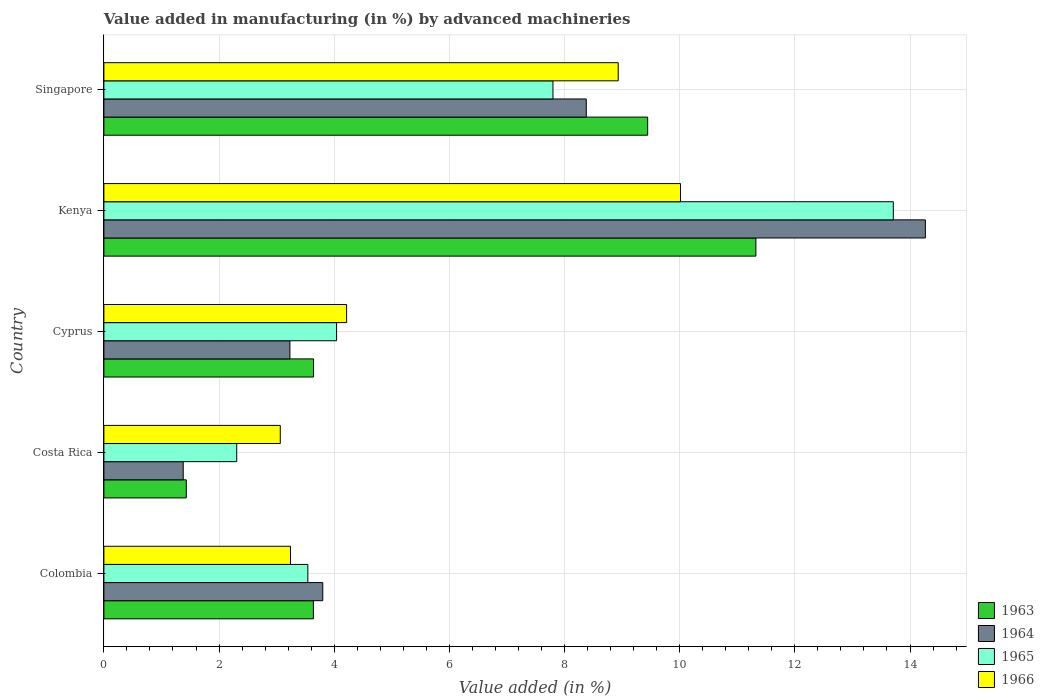Are the number of bars per tick equal to the number of legend labels?
Provide a short and direct response. Yes. How many bars are there on the 2nd tick from the bottom?
Make the answer very short. 4. In how many cases, is the number of bars for a given country not equal to the number of legend labels?
Give a very brief answer. 0. What is the percentage of value added in manufacturing by advanced machineries in 1965 in Singapore?
Provide a short and direct response. 7.8. Across all countries, what is the maximum percentage of value added in manufacturing by advanced machineries in 1966?
Your response must be concise. 10.01. Across all countries, what is the minimum percentage of value added in manufacturing by advanced machineries in 1965?
Your answer should be very brief. 2.31. In which country was the percentage of value added in manufacturing by advanced machineries in 1966 maximum?
Provide a short and direct response. Kenya. In which country was the percentage of value added in manufacturing by advanced machineries in 1964 minimum?
Ensure brevity in your answer.  Costa Rica. What is the total percentage of value added in manufacturing by advanced machineries in 1966 in the graph?
Keep it short and to the point. 29.47. What is the difference between the percentage of value added in manufacturing by advanced machineries in 1965 in Costa Rica and that in Cyprus?
Your answer should be compact. -1.73. What is the difference between the percentage of value added in manufacturing by advanced machineries in 1966 in Kenya and the percentage of value added in manufacturing by advanced machineries in 1963 in Costa Rica?
Keep it short and to the point. 8.58. What is the average percentage of value added in manufacturing by advanced machineries in 1966 per country?
Keep it short and to the point. 5.89. What is the difference between the percentage of value added in manufacturing by advanced machineries in 1963 and percentage of value added in manufacturing by advanced machineries in 1966 in Singapore?
Make the answer very short. 0.51. What is the ratio of the percentage of value added in manufacturing by advanced machineries in 1966 in Cyprus to that in Singapore?
Offer a very short reply. 0.47. What is the difference between the highest and the second highest percentage of value added in manufacturing by advanced machineries in 1964?
Provide a succinct answer. 5.89. What is the difference between the highest and the lowest percentage of value added in manufacturing by advanced machineries in 1965?
Offer a very short reply. 11.4. In how many countries, is the percentage of value added in manufacturing by advanced machineries in 1966 greater than the average percentage of value added in manufacturing by advanced machineries in 1966 taken over all countries?
Keep it short and to the point. 2. What does the 2nd bar from the top in Kenya represents?
Keep it short and to the point. 1965. Is it the case that in every country, the sum of the percentage of value added in manufacturing by advanced machineries in 1964 and percentage of value added in manufacturing by advanced machineries in 1965 is greater than the percentage of value added in manufacturing by advanced machineries in 1966?
Offer a very short reply. Yes. How many bars are there?
Give a very brief answer. 20. What is the difference between two consecutive major ticks on the X-axis?
Your response must be concise. 2. Are the values on the major ticks of X-axis written in scientific E-notation?
Make the answer very short. No. Does the graph contain any zero values?
Provide a succinct answer. No. Where does the legend appear in the graph?
Ensure brevity in your answer.  Bottom right. How many legend labels are there?
Provide a succinct answer. 4. What is the title of the graph?
Provide a succinct answer. Value added in manufacturing (in %) by advanced machineries. What is the label or title of the X-axis?
Your answer should be compact. Value added (in %). What is the label or title of the Y-axis?
Your answer should be compact. Country. What is the Value added (in %) of 1963 in Colombia?
Your answer should be compact. 3.64. What is the Value added (in %) of 1964 in Colombia?
Give a very brief answer. 3.8. What is the Value added (in %) of 1965 in Colombia?
Ensure brevity in your answer.  3.54. What is the Value added (in %) in 1966 in Colombia?
Make the answer very short. 3.24. What is the Value added (in %) in 1963 in Costa Rica?
Give a very brief answer. 1.43. What is the Value added (in %) of 1964 in Costa Rica?
Ensure brevity in your answer.  1.38. What is the Value added (in %) of 1965 in Costa Rica?
Make the answer very short. 2.31. What is the Value added (in %) in 1966 in Costa Rica?
Offer a terse response. 3.06. What is the Value added (in %) in 1963 in Cyprus?
Your response must be concise. 3.64. What is the Value added (in %) of 1964 in Cyprus?
Provide a succinct answer. 3.23. What is the Value added (in %) of 1965 in Cyprus?
Your response must be concise. 4.04. What is the Value added (in %) of 1966 in Cyprus?
Give a very brief answer. 4.22. What is the Value added (in %) of 1963 in Kenya?
Make the answer very short. 11.32. What is the Value added (in %) of 1964 in Kenya?
Keep it short and to the point. 14.27. What is the Value added (in %) of 1965 in Kenya?
Give a very brief answer. 13.71. What is the Value added (in %) in 1966 in Kenya?
Provide a short and direct response. 10.01. What is the Value added (in %) in 1963 in Singapore?
Keep it short and to the point. 9.44. What is the Value added (in %) in 1964 in Singapore?
Your answer should be very brief. 8.38. What is the Value added (in %) of 1965 in Singapore?
Give a very brief answer. 7.8. What is the Value added (in %) in 1966 in Singapore?
Your response must be concise. 8.93. Across all countries, what is the maximum Value added (in %) in 1963?
Make the answer very short. 11.32. Across all countries, what is the maximum Value added (in %) in 1964?
Your answer should be compact. 14.27. Across all countries, what is the maximum Value added (in %) in 1965?
Keep it short and to the point. 13.71. Across all countries, what is the maximum Value added (in %) of 1966?
Make the answer very short. 10.01. Across all countries, what is the minimum Value added (in %) in 1963?
Ensure brevity in your answer.  1.43. Across all countries, what is the minimum Value added (in %) in 1964?
Give a very brief answer. 1.38. Across all countries, what is the minimum Value added (in %) in 1965?
Make the answer very short. 2.31. Across all countries, what is the minimum Value added (in %) in 1966?
Offer a very short reply. 3.06. What is the total Value added (in %) in 1963 in the graph?
Offer a terse response. 29.48. What is the total Value added (in %) of 1964 in the graph?
Provide a short and direct response. 31.05. What is the total Value added (in %) of 1965 in the graph?
Your response must be concise. 31.4. What is the total Value added (in %) in 1966 in the graph?
Your answer should be very brief. 29.47. What is the difference between the Value added (in %) in 1963 in Colombia and that in Costa Rica?
Provide a succinct answer. 2.21. What is the difference between the Value added (in %) of 1964 in Colombia and that in Costa Rica?
Offer a terse response. 2.42. What is the difference between the Value added (in %) in 1965 in Colombia and that in Costa Rica?
Your answer should be very brief. 1.24. What is the difference between the Value added (in %) in 1966 in Colombia and that in Costa Rica?
Give a very brief answer. 0.18. What is the difference between the Value added (in %) in 1963 in Colombia and that in Cyprus?
Make the answer very short. -0. What is the difference between the Value added (in %) in 1964 in Colombia and that in Cyprus?
Give a very brief answer. 0.57. What is the difference between the Value added (in %) of 1965 in Colombia and that in Cyprus?
Keep it short and to the point. -0.5. What is the difference between the Value added (in %) of 1966 in Colombia and that in Cyprus?
Provide a succinct answer. -0.97. What is the difference between the Value added (in %) in 1963 in Colombia and that in Kenya?
Your answer should be very brief. -7.69. What is the difference between the Value added (in %) of 1964 in Colombia and that in Kenya?
Your answer should be very brief. -10.47. What is the difference between the Value added (in %) in 1965 in Colombia and that in Kenya?
Ensure brevity in your answer.  -10.17. What is the difference between the Value added (in %) of 1966 in Colombia and that in Kenya?
Offer a very short reply. -6.77. What is the difference between the Value added (in %) in 1963 in Colombia and that in Singapore?
Offer a terse response. -5.81. What is the difference between the Value added (in %) of 1964 in Colombia and that in Singapore?
Offer a terse response. -4.58. What is the difference between the Value added (in %) of 1965 in Colombia and that in Singapore?
Ensure brevity in your answer.  -4.26. What is the difference between the Value added (in %) of 1966 in Colombia and that in Singapore?
Provide a succinct answer. -5.69. What is the difference between the Value added (in %) in 1963 in Costa Rica and that in Cyprus?
Provide a short and direct response. -2.21. What is the difference between the Value added (in %) of 1964 in Costa Rica and that in Cyprus?
Make the answer very short. -1.85. What is the difference between the Value added (in %) of 1965 in Costa Rica and that in Cyprus?
Provide a succinct answer. -1.73. What is the difference between the Value added (in %) in 1966 in Costa Rica and that in Cyprus?
Keep it short and to the point. -1.15. What is the difference between the Value added (in %) in 1963 in Costa Rica and that in Kenya?
Ensure brevity in your answer.  -9.89. What is the difference between the Value added (in %) in 1964 in Costa Rica and that in Kenya?
Make the answer very short. -12.89. What is the difference between the Value added (in %) of 1965 in Costa Rica and that in Kenya?
Keep it short and to the point. -11.4. What is the difference between the Value added (in %) in 1966 in Costa Rica and that in Kenya?
Provide a short and direct response. -6.95. What is the difference between the Value added (in %) in 1963 in Costa Rica and that in Singapore?
Provide a short and direct response. -8.01. What is the difference between the Value added (in %) in 1964 in Costa Rica and that in Singapore?
Offer a terse response. -7. What is the difference between the Value added (in %) of 1965 in Costa Rica and that in Singapore?
Your answer should be very brief. -5.49. What is the difference between the Value added (in %) in 1966 in Costa Rica and that in Singapore?
Your answer should be very brief. -5.87. What is the difference between the Value added (in %) in 1963 in Cyprus and that in Kenya?
Ensure brevity in your answer.  -7.68. What is the difference between the Value added (in %) of 1964 in Cyprus and that in Kenya?
Provide a succinct answer. -11.04. What is the difference between the Value added (in %) in 1965 in Cyprus and that in Kenya?
Your response must be concise. -9.67. What is the difference between the Value added (in %) of 1966 in Cyprus and that in Kenya?
Give a very brief answer. -5.8. What is the difference between the Value added (in %) of 1963 in Cyprus and that in Singapore?
Give a very brief answer. -5.8. What is the difference between the Value added (in %) in 1964 in Cyprus and that in Singapore?
Make the answer very short. -5.15. What is the difference between the Value added (in %) of 1965 in Cyprus and that in Singapore?
Keep it short and to the point. -3.76. What is the difference between the Value added (in %) of 1966 in Cyprus and that in Singapore?
Offer a very short reply. -4.72. What is the difference between the Value added (in %) of 1963 in Kenya and that in Singapore?
Make the answer very short. 1.88. What is the difference between the Value added (in %) in 1964 in Kenya and that in Singapore?
Give a very brief answer. 5.89. What is the difference between the Value added (in %) in 1965 in Kenya and that in Singapore?
Your answer should be compact. 5.91. What is the difference between the Value added (in %) of 1966 in Kenya and that in Singapore?
Provide a short and direct response. 1.08. What is the difference between the Value added (in %) of 1963 in Colombia and the Value added (in %) of 1964 in Costa Rica?
Offer a terse response. 2.26. What is the difference between the Value added (in %) in 1963 in Colombia and the Value added (in %) in 1965 in Costa Rica?
Keep it short and to the point. 1.33. What is the difference between the Value added (in %) in 1963 in Colombia and the Value added (in %) in 1966 in Costa Rica?
Your answer should be very brief. 0.57. What is the difference between the Value added (in %) of 1964 in Colombia and the Value added (in %) of 1965 in Costa Rica?
Your answer should be very brief. 1.49. What is the difference between the Value added (in %) in 1964 in Colombia and the Value added (in %) in 1966 in Costa Rica?
Provide a succinct answer. 0.74. What is the difference between the Value added (in %) in 1965 in Colombia and the Value added (in %) in 1966 in Costa Rica?
Ensure brevity in your answer.  0.48. What is the difference between the Value added (in %) in 1963 in Colombia and the Value added (in %) in 1964 in Cyprus?
Offer a terse response. 0.41. What is the difference between the Value added (in %) in 1963 in Colombia and the Value added (in %) in 1965 in Cyprus?
Offer a terse response. -0.4. What is the difference between the Value added (in %) in 1963 in Colombia and the Value added (in %) in 1966 in Cyprus?
Ensure brevity in your answer.  -0.58. What is the difference between the Value added (in %) in 1964 in Colombia and the Value added (in %) in 1965 in Cyprus?
Your answer should be very brief. -0.24. What is the difference between the Value added (in %) of 1964 in Colombia and the Value added (in %) of 1966 in Cyprus?
Ensure brevity in your answer.  -0.41. What is the difference between the Value added (in %) of 1965 in Colombia and the Value added (in %) of 1966 in Cyprus?
Keep it short and to the point. -0.67. What is the difference between the Value added (in %) in 1963 in Colombia and the Value added (in %) in 1964 in Kenya?
Provide a succinct answer. -10.63. What is the difference between the Value added (in %) of 1963 in Colombia and the Value added (in %) of 1965 in Kenya?
Provide a succinct answer. -10.07. What is the difference between the Value added (in %) in 1963 in Colombia and the Value added (in %) in 1966 in Kenya?
Provide a succinct answer. -6.38. What is the difference between the Value added (in %) of 1964 in Colombia and the Value added (in %) of 1965 in Kenya?
Make the answer very short. -9.91. What is the difference between the Value added (in %) in 1964 in Colombia and the Value added (in %) in 1966 in Kenya?
Ensure brevity in your answer.  -6.21. What is the difference between the Value added (in %) in 1965 in Colombia and the Value added (in %) in 1966 in Kenya?
Provide a succinct answer. -6.47. What is the difference between the Value added (in %) of 1963 in Colombia and the Value added (in %) of 1964 in Singapore?
Your response must be concise. -4.74. What is the difference between the Value added (in %) of 1963 in Colombia and the Value added (in %) of 1965 in Singapore?
Provide a short and direct response. -4.16. What is the difference between the Value added (in %) in 1963 in Colombia and the Value added (in %) in 1966 in Singapore?
Offer a terse response. -5.29. What is the difference between the Value added (in %) of 1964 in Colombia and the Value added (in %) of 1965 in Singapore?
Keep it short and to the point. -4. What is the difference between the Value added (in %) in 1964 in Colombia and the Value added (in %) in 1966 in Singapore?
Your response must be concise. -5.13. What is the difference between the Value added (in %) of 1965 in Colombia and the Value added (in %) of 1966 in Singapore?
Your answer should be compact. -5.39. What is the difference between the Value added (in %) of 1963 in Costa Rica and the Value added (in %) of 1964 in Cyprus?
Make the answer very short. -1.8. What is the difference between the Value added (in %) of 1963 in Costa Rica and the Value added (in %) of 1965 in Cyprus?
Your answer should be very brief. -2.61. What is the difference between the Value added (in %) in 1963 in Costa Rica and the Value added (in %) in 1966 in Cyprus?
Provide a short and direct response. -2.78. What is the difference between the Value added (in %) in 1964 in Costa Rica and the Value added (in %) in 1965 in Cyprus?
Provide a succinct answer. -2.66. What is the difference between the Value added (in %) of 1964 in Costa Rica and the Value added (in %) of 1966 in Cyprus?
Offer a very short reply. -2.84. What is the difference between the Value added (in %) of 1965 in Costa Rica and the Value added (in %) of 1966 in Cyprus?
Your answer should be compact. -1.91. What is the difference between the Value added (in %) of 1963 in Costa Rica and the Value added (in %) of 1964 in Kenya?
Make the answer very short. -12.84. What is the difference between the Value added (in %) of 1963 in Costa Rica and the Value added (in %) of 1965 in Kenya?
Ensure brevity in your answer.  -12.28. What is the difference between the Value added (in %) in 1963 in Costa Rica and the Value added (in %) in 1966 in Kenya?
Provide a short and direct response. -8.58. What is the difference between the Value added (in %) of 1964 in Costa Rica and the Value added (in %) of 1965 in Kenya?
Your answer should be compact. -12.33. What is the difference between the Value added (in %) of 1964 in Costa Rica and the Value added (in %) of 1966 in Kenya?
Your answer should be very brief. -8.64. What is the difference between the Value added (in %) in 1965 in Costa Rica and the Value added (in %) in 1966 in Kenya?
Your answer should be very brief. -7.71. What is the difference between the Value added (in %) in 1963 in Costa Rica and the Value added (in %) in 1964 in Singapore?
Your answer should be very brief. -6.95. What is the difference between the Value added (in %) of 1963 in Costa Rica and the Value added (in %) of 1965 in Singapore?
Make the answer very short. -6.37. What is the difference between the Value added (in %) in 1963 in Costa Rica and the Value added (in %) in 1966 in Singapore?
Provide a short and direct response. -7.5. What is the difference between the Value added (in %) of 1964 in Costa Rica and the Value added (in %) of 1965 in Singapore?
Keep it short and to the point. -6.42. What is the difference between the Value added (in %) of 1964 in Costa Rica and the Value added (in %) of 1966 in Singapore?
Keep it short and to the point. -7.55. What is the difference between the Value added (in %) of 1965 in Costa Rica and the Value added (in %) of 1966 in Singapore?
Ensure brevity in your answer.  -6.63. What is the difference between the Value added (in %) in 1963 in Cyprus and the Value added (in %) in 1964 in Kenya?
Give a very brief answer. -10.63. What is the difference between the Value added (in %) in 1963 in Cyprus and the Value added (in %) in 1965 in Kenya?
Your answer should be compact. -10.07. What is the difference between the Value added (in %) of 1963 in Cyprus and the Value added (in %) of 1966 in Kenya?
Offer a very short reply. -6.37. What is the difference between the Value added (in %) of 1964 in Cyprus and the Value added (in %) of 1965 in Kenya?
Give a very brief answer. -10.48. What is the difference between the Value added (in %) in 1964 in Cyprus and the Value added (in %) in 1966 in Kenya?
Keep it short and to the point. -6.78. What is the difference between the Value added (in %) in 1965 in Cyprus and the Value added (in %) in 1966 in Kenya?
Make the answer very short. -5.97. What is the difference between the Value added (in %) in 1963 in Cyprus and the Value added (in %) in 1964 in Singapore?
Keep it short and to the point. -4.74. What is the difference between the Value added (in %) of 1963 in Cyprus and the Value added (in %) of 1965 in Singapore?
Offer a very short reply. -4.16. What is the difference between the Value added (in %) in 1963 in Cyprus and the Value added (in %) in 1966 in Singapore?
Your answer should be very brief. -5.29. What is the difference between the Value added (in %) in 1964 in Cyprus and the Value added (in %) in 1965 in Singapore?
Your response must be concise. -4.57. What is the difference between the Value added (in %) of 1964 in Cyprus and the Value added (in %) of 1966 in Singapore?
Keep it short and to the point. -5.7. What is the difference between the Value added (in %) in 1965 in Cyprus and the Value added (in %) in 1966 in Singapore?
Your response must be concise. -4.89. What is the difference between the Value added (in %) of 1963 in Kenya and the Value added (in %) of 1964 in Singapore?
Offer a very short reply. 2.95. What is the difference between the Value added (in %) in 1963 in Kenya and the Value added (in %) in 1965 in Singapore?
Make the answer very short. 3.52. What is the difference between the Value added (in %) in 1963 in Kenya and the Value added (in %) in 1966 in Singapore?
Ensure brevity in your answer.  2.39. What is the difference between the Value added (in %) in 1964 in Kenya and the Value added (in %) in 1965 in Singapore?
Your answer should be compact. 6.47. What is the difference between the Value added (in %) in 1964 in Kenya and the Value added (in %) in 1966 in Singapore?
Offer a terse response. 5.33. What is the difference between the Value added (in %) in 1965 in Kenya and the Value added (in %) in 1966 in Singapore?
Give a very brief answer. 4.78. What is the average Value added (in %) of 1963 per country?
Provide a short and direct response. 5.9. What is the average Value added (in %) of 1964 per country?
Provide a short and direct response. 6.21. What is the average Value added (in %) of 1965 per country?
Make the answer very short. 6.28. What is the average Value added (in %) in 1966 per country?
Provide a short and direct response. 5.89. What is the difference between the Value added (in %) in 1963 and Value added (in %) in 1964 in Colombia?
Your answer should be very brief. -0.16. What is the difference between the Value added (in %) in 1963 and Value added (in %) in 1965 in Colombia?
Keep it short and to the point. 0.1. What is the difference between the Value added (in %) in 1963 and Value added (in %) in 1966 in Colombia?
Give a very brief answer. 0.4. What is the difference between the Value added (in %) of 1964 and Value added (in %) of 1965 in Colombia?
Your response must be concise. 0.26. What is the difference between the Value added (in %) in 1964 and Value added (in %) in 1966 in Colombia?
Give a very brief answer. 0.56. What is the difference between the Value added (in %) in 1965 and Value added (in %) in 1966 in Colombia?
Your answer should be very brief. 0.3. What is the difference between the Value added (in %) of 1963 and Value added (in %) of 1964 in Costa Rica?
Provide a short and direct response. 0.05. What is the difference between the Value added (in %) of 1963 and Value added (in %) of 1965 in Costa Rica?
Your answer should be compact. -0.88. What is the difference between the Value added (in %) in 1963 and Value added (in %) in 1966 in Costa Rica?
Keep it short and to the point. -1.63. What is the difference between the Value added (in %) in 1964 and Value added (in %) in 1965 in Costa Rica?
Make the answer very short. -0.93. What is the difference between the Value added (in %) in 1964 and Value added (in %) in 1966 in Costa Rica?
Your response must be concise. -1.69. What is the difference between the Value added (in %) of 1965 and Value added (in %) of 1966 in Costa Rica?
Your answer should be very brief. -0.76. What is the difference between the Value added (in %) of 1963 and Value added (in %) of 1964 in Cyprus?
Your answer should be very brief. 0.41. What is the difference between the Value added (in %) in 1963 and Value added (in %) in 1965 in Cyprus?
Ensure brevity in your answer.  -0.4. What is the difference between the Value added (in %) in 1963 and Value added (in %) in 1966 in Cyprus?
Give a very brief answer. -0.57. What is the difference between the Value added (in %) in 1964 and Value added (in %) in 1965 in Cyprus?
Provide a short and direct response. -0.81. What is the difference between the Value added (in %) in 1964 and Value added (in %) in 1966 in Cyprus?
Offer a very short reply. -0.98. What is the difference between the Value added (in %) of 1965 and Value added (in %) of 1966 in Cyprus?
Provide a short and direct response. -0.17. What is the difference between the Value added (in %) in 1963 and Value added (in %) in 1964 in Kenya?
Ensure brevity in your answer.  -2.94. What is the difference between the Value added (in %) in 1963 and Value added (in %) in 1965 in Kenya?
Ensure brevity in your answer.  -2.39. What is the difference between the Value added (in %) in 1963 and Value added (in %) in 1966 in Kenya?
Keep it short and to the point. 1.31. What is the difference between the Value added (in %) in 1964 and Value added (in %) in 1965 in Kenya?
Your answer should be very brief. 0.56. What is the difference between the Value added (in %) in 1964 and Value added (in %) in 1966 in Kenya?
Make the answer very short. 4.25. What is the difference between the Value added (in %) in 1965 and Value added (in %) in 1966 in Kenya?
Keep it short and to the point. 3.7. What is the difference between the Value added (in %) of 1963 and Value added (in %) of 1964 in Singapore?
Your answer should be very brief. 1.07. What is the difference between the Value added (in %) of 1963 and Value added (in %) of 1965 in Singapore?
Your answer should be compact. 1.64. What is the difference between the Value added (in %) in 1963 and Value added (in %) in 1966 in Singapore?
Offer a terse response. 0.51. What is the difference between the Value added (in %) of 1964 and Value added (in %) of 1965 in Singapore?
Provide a succinct answer. 0.58. What is the difference between the Value added (in %) in 1964 and Value added (in %) in 1966 in Singapore?
Ensure brevity in your answer.  -0.55. What is the difference between the Value added (in %) in 1965 and Value added (in %) in 1966 in Singapore?
Keep it short and to the point. -1.13. What is the ratio of the Value added (in %) in 1963 in Colombia to that in Costa Rica?
Your answer should be compact. 2.54. What is the ratio of the Value added (in %) of 1964 in Colombia to that in Costa Rica?
Your answer should be very brief. 2.76. What is the ratio of the Value added (in %) of 1965 in Colombia to that in Costa Rica?
Keep it short and to the point. 1.54. What is the ratio of the Value added (in %) in 1966 in Colombia to that in Costa Rica?
Provide a short and direct response. 1.06. What is the ratio of the Value added (in %) of 1963 in Colombia to that in Cyprus?
Keep it short and to the point. 1. What is the ratio of the Value added (in %) of 1964 in Colombia to that in Cyprus?
Your answer should be compact. 1.18. What is the ratio of the Value added (in %) in 1965 in Colombia to that in Cyprus?
Your answer should be very brief. 0.88. What is the ratio of the Value added (in %) of 1966 in Colombia to that in Cyprus?
Your response must be concise. 0.77. What is the ratio of the Value added (in %) of 1963 in Colombia to that in Kenya?
Ensure brevity in your answer.  0.32. What is the ratio of the Value added (in %) of 1964 in Colombia to that in Kenya?
Your response must be concise. 0.27. What is the ratio of the Value added (in %) of 1965 in Colombia to that in Kenya?
Your answer should be very brief. 0.26. What is the ratio of the Value added (in %) in 1966 in Colombia to that in Kenya?
Your answer should be very brief. 0.32. What is the ratio of the Value added (in %) in 1963 in Colombia to that in Singapore?
Give a very brief answer. 0.39. What is the ratio of the Value added (in %) in 1964 in Colombia to that in Singapore?
Provide a short and direct response. 0.45. What is the ratio of the Value added (in %) in 1965 in Colombia to that in Singapore?
Your response must be concise. 0.45. What is the ratio of the Value added (in %) in 1966 in Colombia to that in Singapore?
Provide a succinct answer. 0.36. What is the ratio of the Value added (in %) of 1963 in Costa Rica to that in Cyprus?
Provide a succinct answer. 0.39. What is the ratio of the Value added (in %) in 1964 in Costa Rica to that in Cyprus?
Provide a succinct answer. 0.43. What is the ratio of the Value added (in %) of 1965 in Costa Rica to that in Cyprus?
Offer a terse response. 0.57. What is the ratio of the Value added (in %) of 1966 in Costa Rica to that in Cyprus?
Offer a very short reply. 0.73. What is the ratio of the Value added (in %) in 1963 in Costa Rica to that in Kenya?
Your answer should be compact. 0.13. What is the ratio of the Value added (in %) of 1964 in Costa Rica to that in Kenya?
Give a very brief answer. 0.1. What is the ratio of the Value added (in %) in 1965 in Costa Rica to that in Kenya?
Ensure brevity in your answer.  0.17. What is the ratio of the Value added (in %) of 1966 in Costa Rica to that in Kenya?
Offer a terse response. 0.31. What is the ratio of the Value added (in %) of 1963 in Costa Rica to that in Singapore?
Make the answer very short. 0.15. What is the ratio of the Value added (in %) in 1964 in Costa Rica to that in Singapore?
Provide a short and direct response. 0.16. What is the ratio of the Value added (in %) in 1965 in Costa Rica to that in Singapore?
Your answer should be compact. 0.3. What is the ratio of the Value added (in %) in 1966 in Costa Rica to that in Singapore?
Give a very brief answer. 0.34. What is the ratio of the Value added (in %) in 1963 in Cyprus to that in Kenya?
Offer a terse response. 0.32. What is the ratio of the Value added (in %) in 1964 in Cyprus to that in Kenya?
Your answer should be compact. 0.23. What is the ratio of the Value added (in %) in 1965 in Cyprus to that in Kenya?
Give a very brief answer. 0.29. What is the ratio of the Value added (in %) in 1966 in Cyprus to that in Kenya?
Provide a short and direct response. 0.42. What is the ratio of the Value added (in %) in 1963 in Cyprus to that in Singapore?
Offer a very short reply. 0.39. What is the ratio of the Value added (in %) in 1964 in Cyprus to that in Singapore?
Your answer should be very brief. 0.39. What is the ratio of the Value added (in %) of 1965 in Cyprus to that in Singapore?
Your answer should be very brief. 0.52. What is the ratio of the Value added (in %) in 1966 in Cyprus to that in Singapore?
Ensure brevity in your answer.  0.47. What is the ratio of the Value added (in %) of 1963 in Kenya to that in Singapore?
Give a very brief answer. 1.2. What is the ratio of the Value added (in %) of 1964 in Kenya to that in Singapore?
Ensure brevity in your answer.  1.7. What is the ratio of the Value added (in %) of 1965 in Kenya to that in Singapore?
Ensure brevity in your answer.  1.76. What is the ratio of the Value added (in %) of 1966 in Kenya to that in Singapore?
Offer a terse response. 1.12. What is the difference between the highest and the second highest Value added (in %) in 1963?
Keep it short and to the point. 1.88. What is the difference between the highest and the second highest Value added (in %) of 1964?
Offer a terse response. 5.89. What is the difference between the highest and the second highest Value added (in %) in 1965?
Ensure brevity in your answer.  5.91. What is the difference between the highest and the second highest Value added (in %) of 1966?
Provide a succinct answer. 1.08. What is the difference between the highest and the lowest Value added (in %) in 1963?
Offer a very short reply. 9.89. What is the difference between the highest and the lowest Value added (in %) in 1964?
Make the answer very short. 12.89. What is the difference between the highest and the lowest Value added (in %) of 1965?
Offer a terse response. 11.4. What is the difference between the highest and the lowest Value added (in %) of 1966?
Provide a succinct answer. 6.95. 